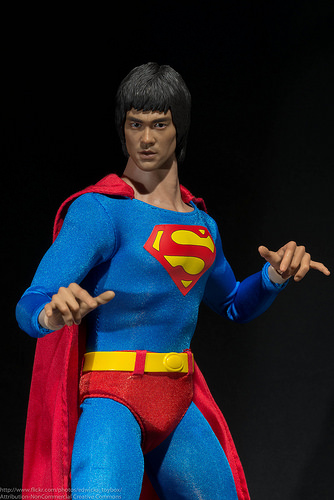<image>
Is there a belt under the pant? No. The belt is not positioned under the pant. The vertical relationship between these objects is different. 